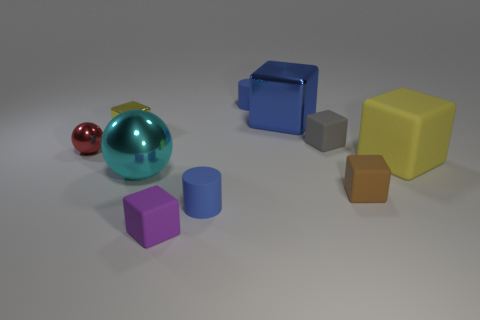Subtract all brown cubes. How many cubes are left? 5 Subtract all tiny purple blocks. How many blocks are left? 5 Subtract all blue blocks. Subtract all purple balls. How many blocks are left? 5 Subtract all cylinders. How many objects are left? 8 Add 10 small cyan matte blocks. How many small cyan matte blocks exist? 10 Subtract 0 purple spheres. How many objects are left? 10 Subtract all large brown matte objects. Subtract all tiny red balls. How many objects are left? 9 Add 8 large cyan objects. How many large cyan objects are left? 9 